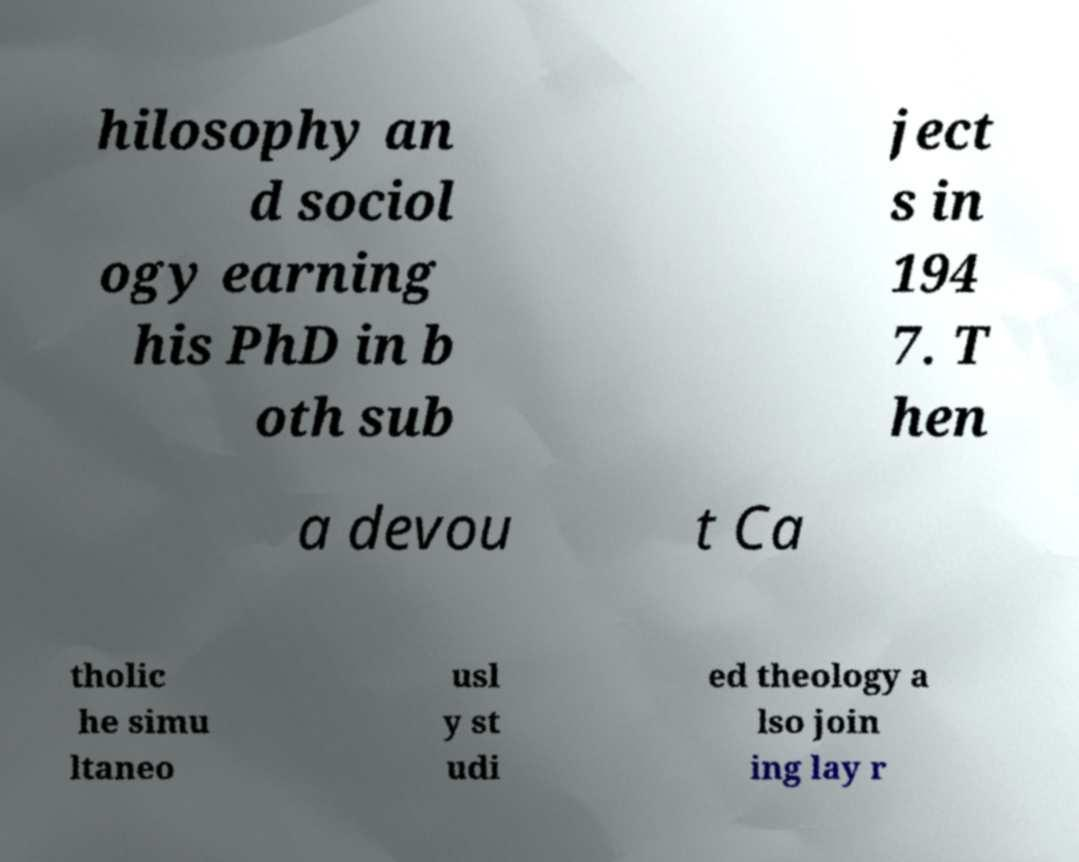Can you read and provide the text displayed in the image?This photo seems to have some interesting text. Can you extract and type it out for me? hilosophy an d sociol ogy earning his PhD in b oth sub ject s in 194 7. T hen a devou t Ca tholic he simu ltaneo usl y st udi ed theology a lso join ing lay r 